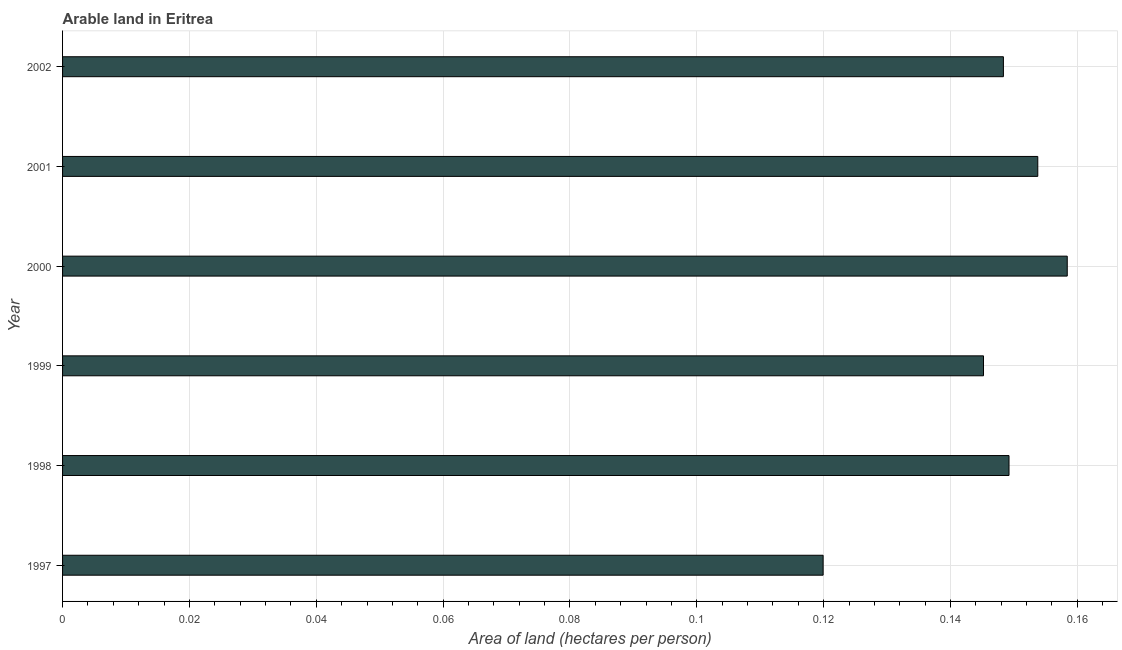What is the title of the graph?
Make the answer very short. Arable land in Eritrea. What is the label or title of the X-axis?
Offer a very short reply. Area of land (hectares per person). What is the label or title of the Y-axis?
Your answer should be very brief. Year. What is the area of arable land in 2002?
Offer a terse response. 0.15. Across all years, what is the maximum area of arable land?
Make the answer very short. 0.16. Across all years, what is the minimum area of arable land?
Offer a terse response. 0.12. In which year was the area of arable land minimum?
Ensure brevity in your answer.  1997. What is the sum of the area of arable land?
Offer a very short reply. 0.87. What is the difference between the area of arable land in 1999 and 2000?
Your response must be concise. -0.01. What is the average area of arable land per year?
Your answer should be compact. 0.15. What is the median area of arable land?
Your answer should be very brief. 0.15. Do a majority of the years between 1998 and 2000 (inclusive) have area of arable land greater than 0.052 hectares per person?
Offer a terse response. Yes. What is the ratio of the area of arable land in 1998 to that in 2001?
Your response must be concise. 0.97. Is the area of arable land in 1997 less than that in 1999?
Offer a very short reply. Yes. Is the difference between the area of arable land in 1999 and 2002 greater than the difference between any two years?
Provide a succinct answer. No. What is the difference between the highest and the second highest area of arable land?
Your response must be concise. 0.01. Is the sum of the area of arable land in 1997 and 2000 greater than the maximum area of arable land across all years?
Offer a very short reply. Yes. How many bars are there?
Make the answer very short. 6. Are all the bars in the graph horizontal?
Your answer should be very brief. Yes. What is the Area of land (hectares per person) of 1997?
Give a very brief answer. 0.12. What is the Area of land (hectares per person) of 1998?
Your response must be concise. 0.15. What is the Area of land (hectares per person) in 1999?
Keep it short and to the point. 0.15. What is the Area of land (hectares per person) in 2000?
Your answer should be very brief. 0.16. What is the Area of land (hectares per person) of 2001?
Make the answer very short. 0.15. What is the Area of land (hectares per person) of 2002?
Offer a terse response. 0.15. What is the difference between the Area of land (hectares per person) in 1997 and 1998?
Provide a succinct answer. -0.03. What is the difference between the Area of land (hectares per person) in 1997 and 1999?
Your answer should be compact. -0.03. What is the difference between the Area of land (hectares per person) in 1997 and 2000?
Give a very brief answer. -0.04. What is the difference between the Area of land (hectares per person) in 1997 and 2001?
Provide a short and direct response. -0.03. What is the difference between the Area of land (hectares per person) in 1997 and 2002?
Your response must be concise. -0.03. What is the difference between the Area of land (hectares per person) in 1998 and 1999?
Provide a succinct answer. 0. What is the difference between the Area of land (hectares per person) in 1998 and 2000?
Ensure brevity in your answer.  -0.01. What is the difference between the Area of land (hectares per person) in 1998 and 2001?
Provide a short and direct response. -0. What is the difference between the Area of land (hectares per person) in 1998 and 2002?
Offer a terse response. 0. What is the difference between the Area of land (hectares per person) in 1999 and 2000?
Ensure brevity in your answer.  -0.01. What is the difference between the Area of land (hectares per person) in 1999 and 2001?
Keep it short and to the point. -0.01. What is the difference between the Area of land (hectares per person) in 1999 and 2002?
Your answer should be compact. -0. What is the difference between the Area of land (hectares per person) in 2000 and 2001?
Ensure brevity in your answer.  0. What is the difference between the Area of land (hectares per person) in 2000 and 2002?
Ensure brevity in your answer.  0.01. What is the difference between the Area of land (hectares per person) in 2001 and 2002?
Offer a terse response. 0.01. What is the ratio of the Area of land (hectares per person) in 1997 to that in 1998?
Ensure brevity in your answer.  0.8. What is the ratio of the Area of land (hectares per person) in 1997 to that in 1999?
Your answer should be very brief. 0.83. What is the ratio of the Area of land (hectares per person) in 1997 to that in 2000?
Your response must be concise. 0.76. What is the ratio of the Area of land (hectares per person) in 1997 to that in 2001?
Give a very brief answer. 0.78. What is the ratio of the Area of land (hectares per person) in 1997 to that in 2002?
Your response must be concise. 0.81. What is the ratio of the Area of land (hectares per person) in 1998 to that in 1999?
Provide a succinct answer. 1.03. What is the ratio of the Area of land (hectares per person) in 1998 to that in 2000?
Provide a succinct answer. 0.94. What is the ratio of the Area of land (hectares per person) in 1998 to that in 2001?
Provide a short and direct response. 0.97. What is the ratio of the Area of land (hectares per person) in 1999 to that in 2000?
Offer a terse response. 0.92. What is the ratio of the Area of land (hectares per person) in 1999 to that in 2001?
Offer a terse response. 0.94. What is the ratio of the Area of land (hectares per person) in 1999 to that in 2002?
Your answer should be compact. 0.98. What is the ratio of the Area of land (hectares per person) in 2000 to that in 2001?
Keep it short and to the point. 1.03. What is the ratio of the Area of land (hectares per person) in 2000 to that in 2002?
Give a very brief answer. 1.07. What is the ratio of the Area of land (hectares per person) in 2001 to that in 2002?
Provide a succinct answer. 1.04. 